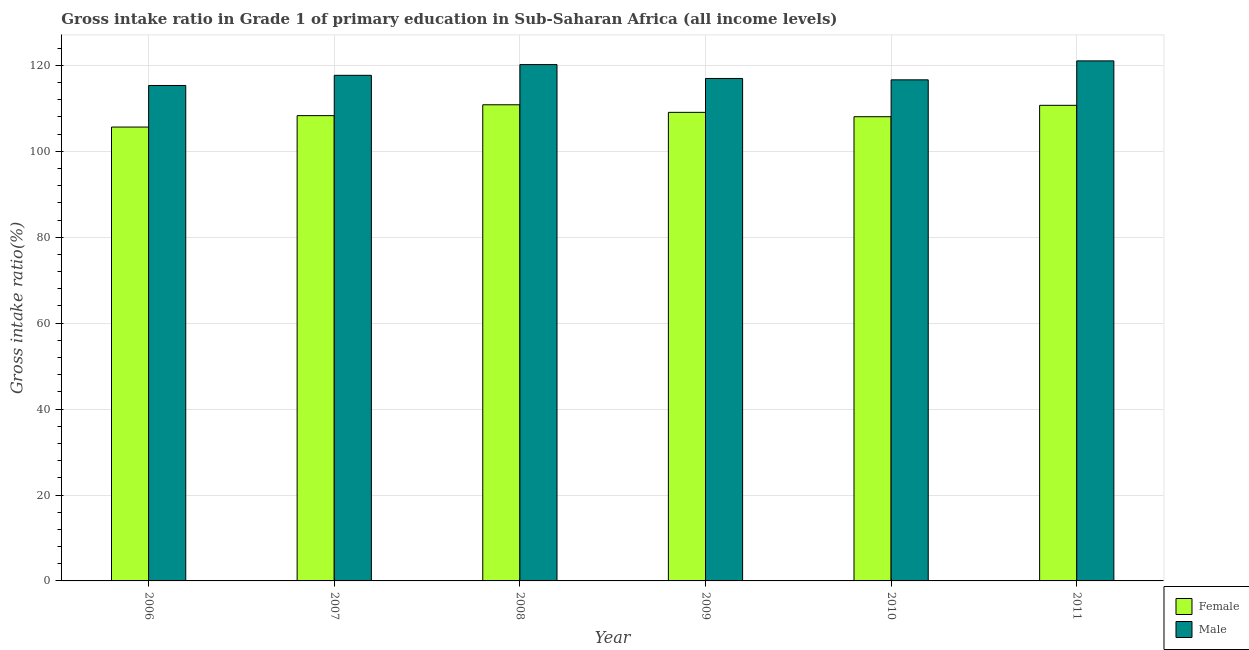Are the number of bars per tick equal to the number of legend labels?
Your answer should be compact. Yes. How many bars are there on the 4th tick from the right?
Your answer should be compact. 2. In how many cases, is the number of bars for a given year not equal to the number of legend labels?
Your answer should be compact. 0. What is the gross intake ratio(male) in 2011?
Ensure brevity in your answer.  121.05. Across all years, what is the maximum gross intake ratio(female)?
Your response must be concise. 110.84. Across all years, what is the minimum gross intake ratio(male)?
Your answer should be compact. 115.33. What is the total gross intake ratio(male) in the graph?
Make the answer very short. 707.86. What is the difference between the gross intake ratio(female) in 2006 and that in 2009?
Offer a terse response. -3.42. What is the difference between the gross intake ratio(male) in 2010 and the gross intake ratio(female) in 2006?
Your response must be concise. 1.32. What is the average gross intake ratio(male) per year?
Make the answer very short. 117.98. In how many years, is the gross intake ratio(female) greater than 40 %?
Provide a short and direct response. 6. What is the ratio of the gross intake ratio(male) in 2006 to that in 2011?
Provide a short and direct response. 0.95. Is the gross intake ratio(male) in 2008 less than that in 2011?
Offer a very short reply. Yes. What is the difference between the highest and the second highest gross intake ratio(male)?
Provide a short and direct response. 0.86. What is the difference between the highest and the lowest gross intake ratio(male)?
Give a very brief answer. 5.73. What does the 2nd bar from the right in 2008 represents?
Offer a very short reply. Female. How many years are there in the graph?
Give a very brief answer. 6. What is the difference between two consecutive major ticks on the Y-axis?
Give a very brief answer. 20. Are the values on the major ticks of Y-axis written in scientific E-notation?
Your answer should be compact. No. Does the graph contain any zero values?
Offer a terse response. No. Where does the legend appear in the graph?
Offer a very short reply. Bottom right. How many legend labels are there?
Your answer should be very brief. 2. What is the title of the graph?
Your answer should be very brief. Gross intake ratio in Grade 1 of primary education in Sub-Saharan Africa (all income levels). Does "From Government" appear as one of the legend labels in the graph?
Provide a short and direct response. No. What is the label or title of the X-axis?
Offer a terse response. Year. What is the label or title of the Y-axis?
Offer a very short reply. Gross intake ratio(%). What is the Gross intake ratio(%) in Female in 2006?
Your answer should be very brief. 105.65. What is the Gross intake ratio(%) in Male in 2006?
Provide a short and direct response. 115.33. What is the Gross intake ratio(%) of Female in 2007?
Ensure brevity in your answer.  108.31. What is the Gross intake ratio(%) in Male in 2007?
Your answer should be very brief. 117.69. What is the Gross intake ratio(%) of Female in 2008?
Your answer should be very brief. 110.84. What is the Gross intake ratio(%) of Male in 2008?
Provide a succinct answer. 120.19. What is the Gross intake ratio(%) in Female in 2009?
Keep it short and to the point. 109.07. What is the Gross intake ratio(%) of Male in 2009?
Your response must be concise. 116.96. What is the Gross intake ratio(%) of Female in 2010?
Make the answer very short. 108.06. What is the Gross intake ratio(%) in Male in 2010?
Offer a terse response. 116.64. What is the Gross intake ratio(%) in Female in 2011?
Your answer should be compact. 110.71. What is the Gross intake ratio(%) in Male in 2011?
Offer a very short reply. 121.05. Across all years, what is the maximum Gross intake ratio(%) in Female?
Provide a short and direct response. 110.84. Across all years, what is the maximum Gross intake ratio(%) in Male?
Your response must be concise. 121.05. Across all years, what is the minimum Gross intake ratio(%) in Female?
Give a very brief answer. 105.65. Across all years, what is the minimum Gross intake ratio(%) in Male?
Keep it short and to the point. 115.33. What is the total Gross intake ratio(%) of Female in the graph?
Your response must be concise. 652.63. What is the total Gross intake ratio(%) of Male in the graph?
Keep it short and to the point. 707.86. What is the difference between the Gross intake ratio(%) in Female in 2006 and that in 2007?
Your response must be concise. -2.66. What is the difference between the Gross intake ratio(%) in Male in 2006 and that in 2007?
Provide a succinct answer. -2.36. What is the difference between the Gross intake ratio(%) of Female in 2006 and that in 2008?
Keep it short and to the point. -5.19. What is the difference between the Gross intake ratio(%) in Male in 2006 and that in 2008?
Ensure brevity in your answer.  -4.86. What is the difference between the Gross intake ratio(%) of Female in 2006 and that in 2009?
Your answer should be very brief. -3.42. What is the difference between the Gross intake ratio(%) in Male in 2006 and that in 2009?
Your answer should be compact. -1.64. What is the difference between the Gross intake ratio(%) of Female in 2006 and that in 2010?
Your answer should be compact. -2.41. What is the difference between the Gross intake ratio(%) of Male in 2006 and that in 2010?
Make the answer very short. -1.32. What is the difference between the Gross intake ratio(%) in Female in 2006 and that in 2011?
Ensure brevity in your answer.  -5.06. What is the difference between the Gross intake ratio(%) in Male in 2006 and that in 2011?
Give a very brief answer. -5.73. What is the difference between the Gross intake ratio(%) in Female in 2007 and that in 2008?
Your answer should be compact. -2.53. What is the difference between the Gross intake ratio(%) of Male in 2007 and that in 2008?
Your answer should be compact. -2.5. What is the difference between the Gross intake ratio(%) in Female in 2007 and that in 2009?
Give a very brief answer. -0.76. What is the difference between the Gross intake ratio(%) of Male in 2007 and that in 2009?
Offer a terse response. 0.73. What is the difference between the Gross intake ratio(%) in Male in 2007 and that in 2010?
Your answer should be very brief. 1.05. What is the difference between the Gross intake ratio(%) of Female in 2007 and that in 2011?
Ensure brevity in your answer.  -2.4. What is the difference between the Gross intake ratio(%) of Male in 2007 and that in 2011?
Offer a terse response. -3.36. What is the difference between the Gross intake ratio(%) of Female in 2008 and that in 2009?
Offer a terse response. 1.76. What is the difference between the Gross intake ratio(%) of Male in 2008 and that in 2009?
Make the answer very short. 3.23. What is the difference between the Gross intake ratio(%) of Female in 2008 and that in 2010?
Your answer should be compact. 2.78. What is the difference between the Gross intake ratio(%) in Male in 2008 and that in 2010?
Offer a very short reply. 3.55. What is the difference between the Gross intake ratio(%) in Female in 2008 and that in 2011?
Keep it short and to the point. 0.13. What is the difference between the Gross intake ratio(%) of Male in 2008 and that in 2011?
Your response must be concise. -0.86. What is the difference between the Gross intake ratio(%) in Female in 2009 and that in 2010?
Offer a terse response. 1.01. What is the difference between the Gross intake ratio(%) in Male in 2009 and that in 2010?
Offer a terse response. 0.32. What is the difference between the Gross intake ratio(%) in Female in 2009 and that in 2011?
Your answer should be very brief. -1.64. What is the difference between the Gross intake ratio(%) of Male in 2009 and that in 2011?
Your response must be concise. -4.09. What is the difference between the Gross intake ratio(%) of Female in 2010 and that in 2011?
Your answer should be very brief. -2.65. What is the difference between the Gross intake ratio(%) of Male in 2010 and that in 2011?
Offer a very short reply. -4.41. What is the difference between the Gross intake ratio(%) of Female in 2006 and the Gross intake ratio(%) of Male in 2007?
Your answer should be compact. -12.04. What is the difference between the Gross intake ratio(%) of Female in 2006 and the Gross intake ratio(%) of Male in 2008?
Your response must be concise. -14.54. What is the difference between the Gross intake ratio(%) in Female in 2006 and the Gross intake ratio(%) in Male in 2009?
Provide a succinct answer. -11.31. What is the difference between the Gross intake ratio(%) in Female in 2006 and the Gross intake ratio(%) in Male in 2010?
Provide a short and direct response. -10.99. What is the difference between the Gross intake ratio(%) in Female in 2006 and the Gross intake ratio(%) in Male in 2011?
Your response must be concise. -15.4. What is the difference between the Gross intake ratio(%) in Female in 2007 and the Gross intake ratio(%) in Male in 2008?
Provide a short and direct response. -11.88. What is the difference between the Gross intake ratio(%) in Female in 2007 and the Gross intake ratio(%) in Male in 2009?
Your response must be concise. -8.65. What is the difference between the Gross intake ratio(%) in Female in 2007 and the Gross intake ratio(%) in Male in 2010?
Give a very brief answer. -8.33. What is the difference between the Gross intake ratio(%) of Female in 2007 and the Gross intake ratio(%) of Male in 2011?
Make the answer very short. -12.75. What is the difference between the Gross intake ratio(%) of Female in 2008 and the Gross intake ratio(%) of Male in 2009?
Your answer should be compact. -6.13. What is the difference between the Gross intake ratio(%) of Female in 2008 and the Gross intake ratio(%) of Male in 2010?
Provide a short and direct response. -5.81. What is the difference between the Gross intake ratio(%) of Female in 2008 and the Gross intake ratio(%) of Male in 2011?
Offer a very short reply. -10.22. What is the difference between the Gross intake ratio(%) in Female in 2009 and the Gross intake ratio(%) in Male in 2010?
Give a very brief answer. -7.57. What is the difference between the Gross intake ratio(%) in Female in 2009 and the Gross intake ratio(%) in Male in 2011?
Make the answer very short. -11.98. What is the difference between the Gross intake ratio(%) in Female in 2010 and the Gross intake ratio(%) in Male in 2011?
Your response must be concise. -13. What is the average Gross intake ratio(%) of Female per year?
Your response must be concise. 108.77. What is the average Gross intake ratio(%) in Male per year?
Provide a short and direct response. 117.98. In the year 2006, what is the difference between the Gross intake ratio(%) in Female and Gross intake ratio(%) in Male?
Your answer should be compact. -9.68. In the year 2007, what is the difference between the Gross intake ratio(%) in Female and Gross intake ratio(%) in Male?
Give a very brief answer. -9.38. In the year 2008, what is the difference between the Gross intake ratio(%) in Female and Gross intake ratio(%) in Male?
Keep it short and to the point. -9.35. In the year 2009, what is the difference between the Gross intake ratio(%) in Female and Gross intake ratio(%) in Male?
Your answer should be compact. -7.89. In the year 2010, what is the difference between the Gross intake ratio(%) of Female and Gross intake ratio(%) of Male?
Ensure brevity in your answer.  -8.58. In the year 2011, what is the difference between the Gross intake ratio(%) in Female and Gross intake ratio(%) in Male?
Make the answer very short. -10.35. What is the ratio of the Gross intake ratio(%) in Female in 2006 to that in 2007?
Offer a very short reply. 0.98. What is the ratio of the Gross intake ratio(%) in Male in 2006 to that in 2007?
Provide a succinct answer. 0.98. What is the ratio of the Gross intake ratio(%) of Female in 2006 to that in 2008?
Provide a short and direct response. 0.95. What is the ratio of the Gross intake ratio(%) of Male in 2006 to that in 2008?
Offer a very short reply. 0.96. What is the ratio of the Gross intake ratio(%) of Female in 2006 to that in 2009?
Ensure brevity in your answer.  0.97. What is the ratio of the Gross intake ratio(%) in Male in 2006 to that in 2009?
Provide a succinct answer. 0.99. What is the ratio of the Gross intake ratio(%) of Female in 2006 to that in 2010?
Give a very brief answer. 0.98. What is the ratio of the Gross intake ratio(%) of Male in 2006 to that in 2010?
Offer a terse response. 0.99. What is the ratio of the Gross intake ratio(%) of Female in 2006 to that in 2011?
Provide a short and direct response. 0.95. What is the ratio of the Gross intake ratio(%) in Male in 2006 to that in 2011?
Offer a terse response. 0.95. What is the ratio of the Gross intake ratio(%) in Female in 2007 to that in 2008?
Offer a very short reply. 0.98. What is the ratio of the Gross intake ratio(%) in Male in 2007 to that in 2008?
Your answer should be compact. 0.98. What is the ratio of the Gross intake ratio(%) in Female in 2007 to that in 2010?
Your answer should be compact. 1. What is the ratio of the Gross intake ratio(%) in Female in 2007 to that in 2011?
Give a very brief answer. 0.98. What is the ratio of the Gross intake ratio(%) of Male in 2007 to that in 2011?
Provide a succinct answer. 0.97. What is the ratio of the Gross intake ratio(%) in Female in 2008 to that in 2009?
Offer a terse response. 1.02. What is the ratio of the Gross intake ratio(%) in Male in 2008 to that in 2009?
Keep it short and to the point. 1.03. What is the ratio of the Gross intake ratio(%) of Female in 2008 to that in 2010?
Offer a very short reply. 1.03. What is the ratio of the Gross intake ratio(%) of Male in 2008 to that in 2010?
Provide a short and direct response. 1.03. What is the ratio of the Gross intake ratio(%) of Female in 2009 to that in 2010?
Give a very brief answer. 1.01. What is the ratio of the Gross intake ratio(%) in Female in 2009 to that in 2011?
Ensure brevity in your answer.  0.99. What is the ratio of the Gross intake ratio(%) in Male in 2009 to that in 2011?
Make the answer very short. 0.97. What is the ratio of the Gross intake ratio(%) in Female in 2010 to that in 2011?
Offer a terse response. 0.98. What is the ratio of the Gross intake ratio(%) in Male in 2010 to that in 2011?
Your answer should be very brief. 0.96. What is the difference between the highest and the second highest Gross intake ratio(%) of Female?
Keep it short and to the point. 0.13. What is the difference between the highest and the second highest Gross intake ratio(%) in Male?
Your response must be concise. 0.86. What is the difference between the highest and the lowest Gross intake ratio(%) of Female?
Make the answer very short. 5.19. What is the difference between the highest and the lowest Gross intake ratio(%) of Male?
Offer a very short reply. 5.73. 